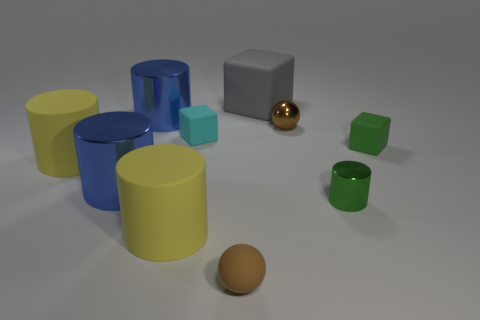Subtract 2 cylinders. How many cylinders are left? 3 Subtract all blue cylinders. How many cylinders are left? 3 Subtract all green cylinders. How many cylinders are left? 4 Subtract all cyan cylinders. Subtract all brown cubes. How many cylinders are left? 5 Subtract all balls. How many objects are left? 8 Add 4 rubber cylinders. How many rubber cylinders are left? 6 Add 7 tiny brown shiny cylinders. How many tiny brown shiny cylinders exist? 7 Subtract 1 green cylinders. How many objects are left? 9 Subtract all gray matte blocks. Subtract all tiny rubber things. How many objects are left? 6 